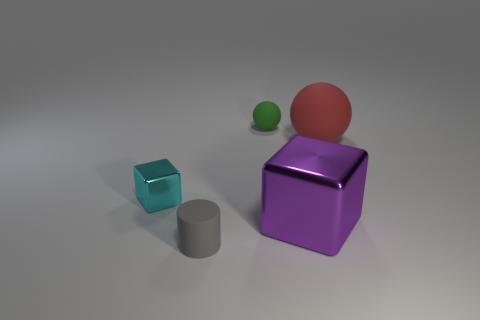Add 3 large gray rubber objects. How many objects exist? 8 Subtract all purple cubes. How many yellow balls are left? 0 Subtract all small cylinders. Subtract all small spheres. How many objects are left? 3 Add 5 tiny cyan objects. How many tiny cyan objects are left? 6 Add 4 gray objects. How many gray objects exist? 5 Subtract 0 cyan cylinders. How many objects are left? 5 Subtract all cylinders. How many objects are left? 4 Subtract 1 cylinders. How many cylinders are left? 0 Subtract all brown cylinders. Subtract all gray blocks. How many cylinders are left? 1 